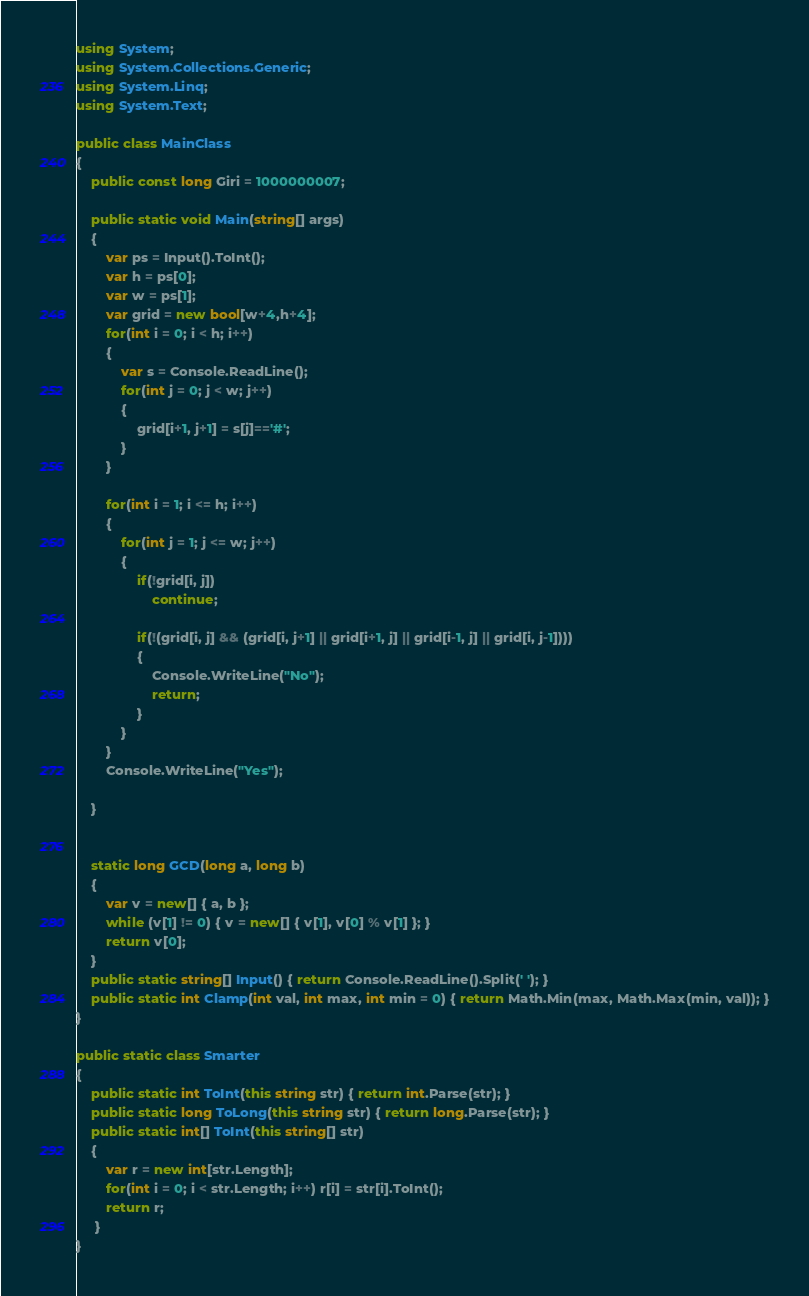Convert code to text. <code><loc_0><loc_0><loc_500><loc_500><_C#_>using System;
using System.Collections.Generic;
using System.Linq;
using System.Text;

public class MainClass
{
	public const long Giri = 1000000007;

	public static void Main(string[] args)
	{
		var ps = Input().ToInt();
		var h = ps[0];
		var w = ps[1];
		var grid = new bool[w+4,h+4];
		for(int i = 0; i < h; i++)
		{
			var s = Console.ReadLine();
			for(int j = 0; j < w; j++)
			{
				grid[i+1, j+1] = s[j]=='#';
			}
		}
		
		for(int i = 1; i <= h; i++)
		{
			for(int j = 1; j <= w; j++)
			{
				if(!grid[i, j])
					continue;
					
				if(!(grid[i, j] && (grid[i, j+1] || grid[i+1, j] || grid[i-1, j] || grid[i, j-1])))
				{
					Console.WriteLine("No");
					return;
				}
			}
		}
		Console.WriteLine("Yes");
		
	}
	

	static long GCD(long a, long b)
	{
		var v = new[] { a, b };
		while (v[1] != 0) { v = new[] { v[1], v[0] % v[1] }; }
		return v[0];
	}
	public static string[] Input() { return Console.ReadLine().Split(' '); }
	public static int Clamp(int val, int max, int min = 0) { return Math.Min(max, Math.Max(min, val)); }
}

public static class Smarter
{
	public static int ToInt(this string str) { return int.Parse(str); }
	public static long ToLong(this string str) { return long.Parse(str); }
	public static int[] ToInt(this string[] str)
	{
		var r = new int[str.Length];
		for(int i = 0; i < str.Length; i++) r[i] = str[i].ToInt();
		return r;
	 }
}

</code> 